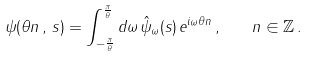Convert formula to latex. <formula><loc_0><loc_0><loc_500><loc_500>\psi ( \theta n \, , \, s ) = \int _ { - \frac { \pi } { \theta } } ^ { \frac { \pi } { \theta } } d \omega \, \hat { \psi } _ { \omega } ( s ) \, e ^ { i \omega \theta n } \, , \quad n \in \mathbb { Z } \, .</formula> 